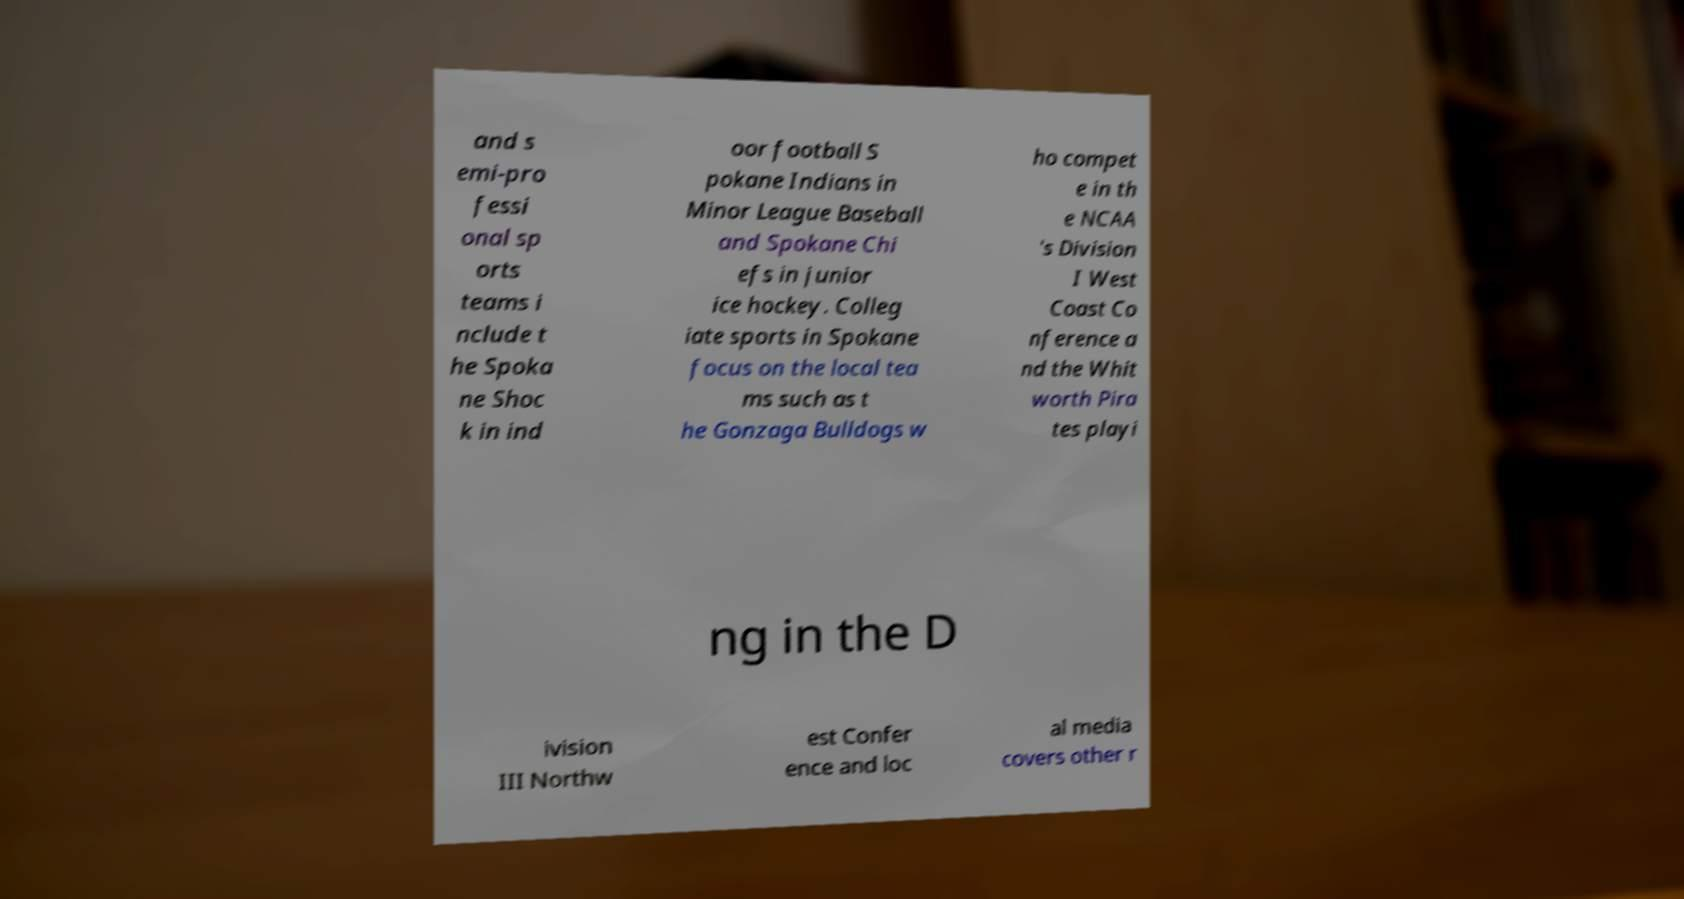Please identify and transcribe the text found in this image. and s emi-pro fessi onal sp orts teams i nclude t he Spoka ne Shoc k in ind oor football S pokane Indians in Minor League Baseball and Spokane Chi efs in junior ice hockey. Colleg iate sports in Spokane focus on the local tea ms such as t he Gonzaga Bulldogs w ho compet e in th e NCAA 's Division I West Coast Co nference a nd the Whit worth Pira tes playi ng in the D ivision III Northw est Confer ence and loc al media covers other r 